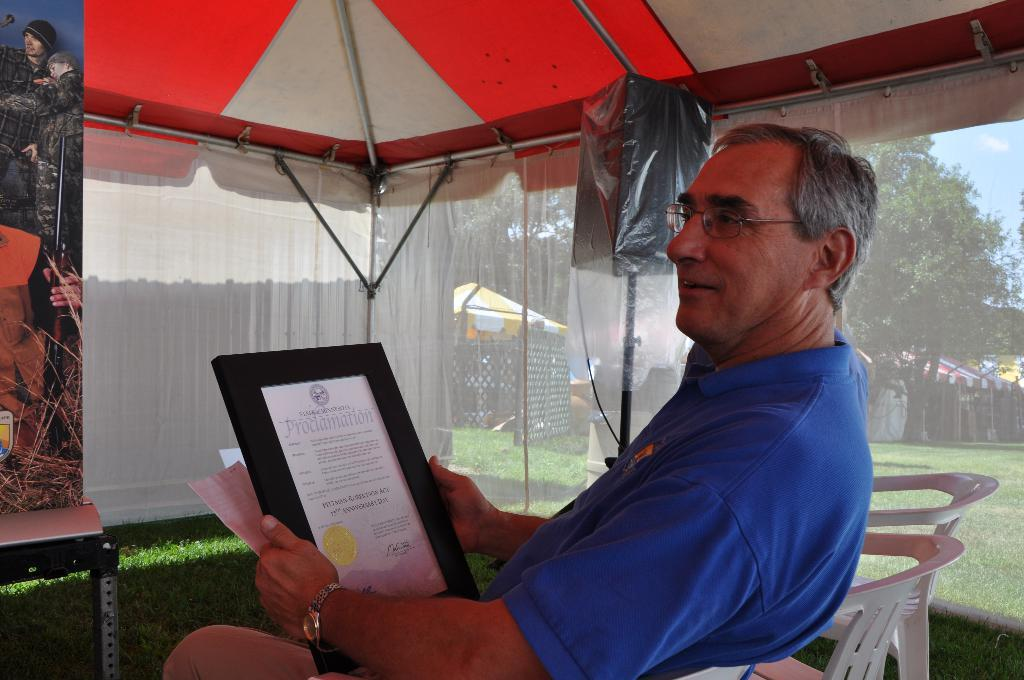What type of furniture can be seen in the image? There are chairs in the image. What type of natural environment is visible in the image? There is grass, trees, and tents in the image. What type of covering is present on the windows in the image? There are curtains in the image. What type of signage is visible in the image? There is a banner in the image. What type of surface is present for placing objects in the image? There is a table in the image. What is the man wearing in the image? The man is wearing a blue t-shirt in the image. What object is the man holding in the image? The man is holding a photo frame in the image. How much tax does the farmer pay for the land in the image? There is no farmer or mention of tax in the image. What type of light source is illuminating the scene in the image? The image does not provide information about a light source; it only shows the objects and people present. 